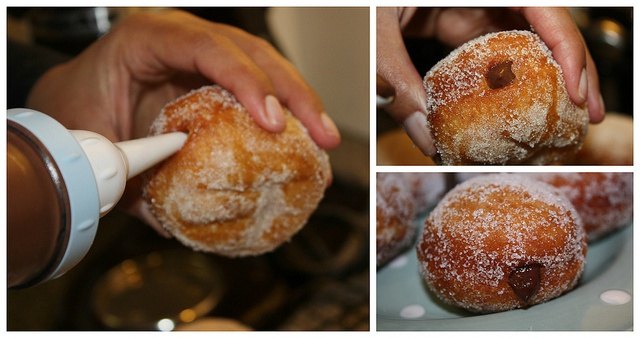Describe the objects in this image and their specific colors. I can see people in white, brown, and maroon tones, donut in white, brown, gray, tan, and maroon tones, donut in white, maroon, darkgray, brown, and gray tones, donut in white, brown, maroon, gray, and tan tones, and people in white, brown, maroon, and black tones in this image. 